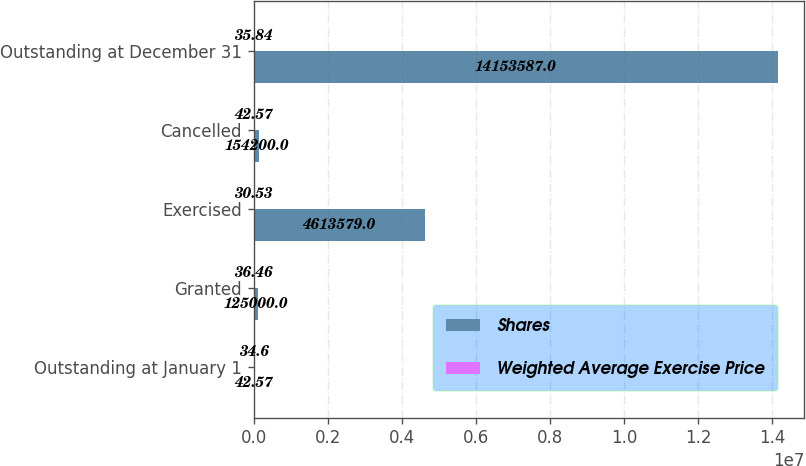<chart> <loc_0><loc_0><loc_500><loc_500><stacked_bar_chart><ecel><fcel>Outstanding at January 1<fcel>Granted<fcel>Exercised<fcel>Cancelled<fcel>Outstanding at December 31<nl><fcel>Shares<fcel>42.57<fcel>125000<fcel>4.61358e+06<fcel>154200<fcel>1.41536e+07<nl><fcel>Weighted Average Exercise Price<fcel>34.6<fcel>36.46<fcel>30.53<fcel>42.57<fcel>35.84<nl></chart> 